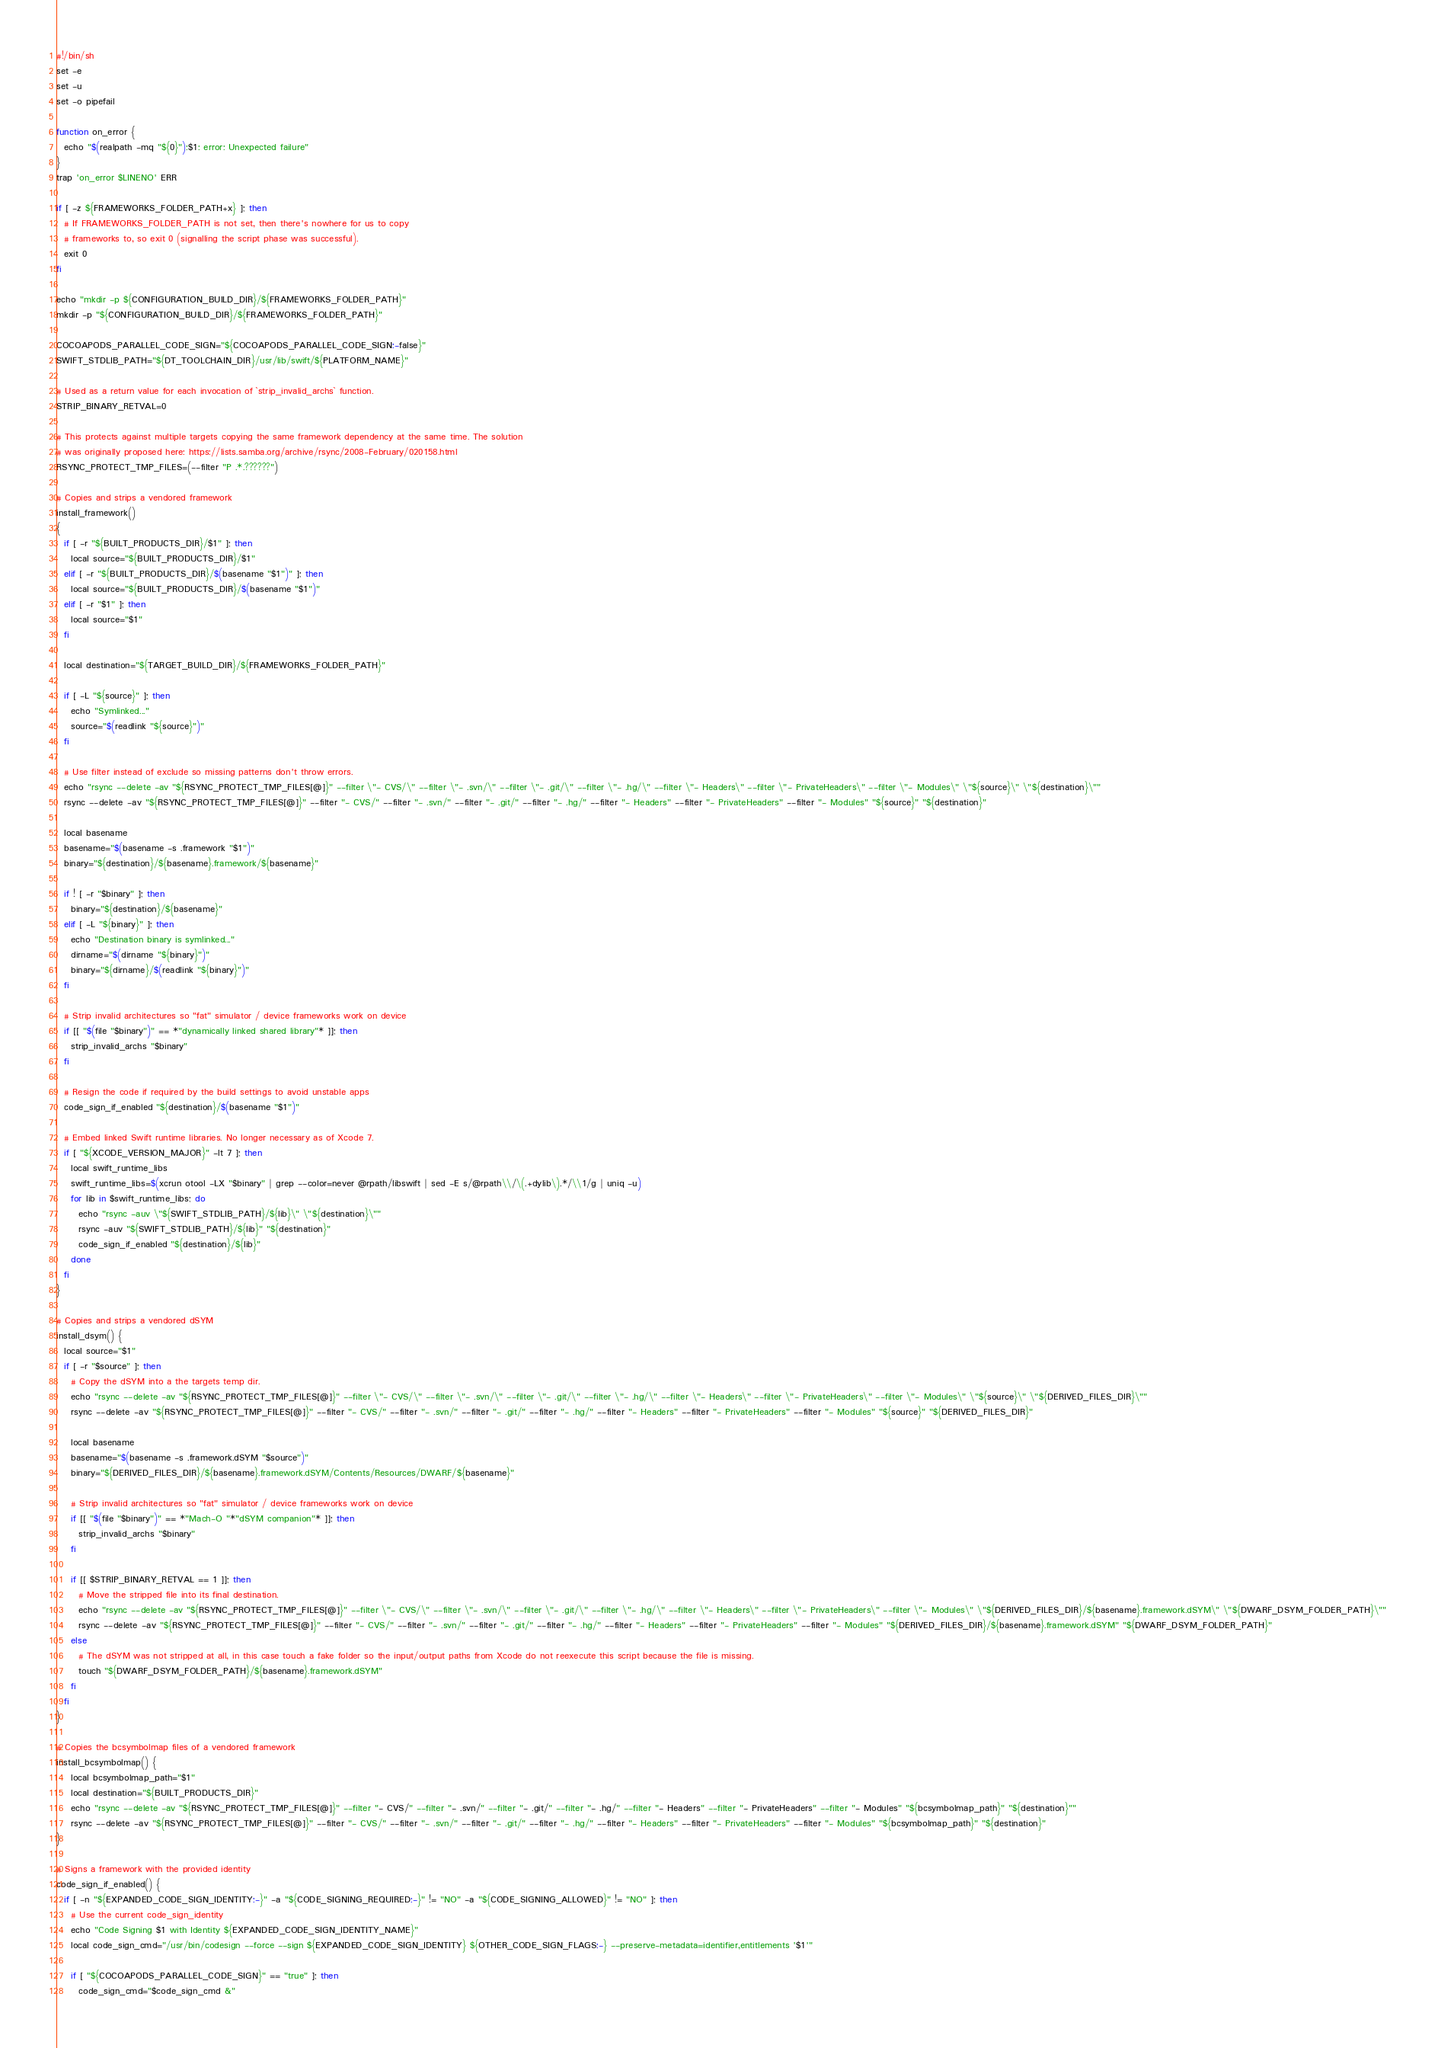<code> <loc_0><loc_0><loc_500><loc_500><_Bash_>#!/bin/sh
set -e
set -u
set -o pipefail

function on_error {
  echo "$(realpath -mq "${0}"):$1: error: Unexpected failure"
}
trap 'on_error $LINENO' ERR

if [ -z ${FRAMEWORKS_FOLDER_PATH+x} ]; then
  # If FRAMEWORKS_FOLDER_PATH is not set, then there's nowhere for us to copy
  # frameworks to, so exit 0 (signalling the script phase was successful).
  exit 0
fi

echo "mkdir -p ${CONFIGURATION_BUILD_DIR}/${FRAMEWORKS_FOLDER_PATH}"
mkdir -p "${CONFIGURATION_BUILD_DIR}/${FRAMEWORKS_FOLDER_PATH}"

COCOAPODS_PARALLEL_CODE_SIGN="${COCOAPODS_PARALLEL_CODE_SIGN:-false}"
SWIFT_STDLIB_PATH="${DT_TOOLCHAIN_DIR}/usr/lib/swift/${PLATFORM_NAME}"

# Used as a return value for each invocation of `strip_invalid_archs` function.
STRIP_BINARY_RETVAL=0

# This protects against multiple targets copying the same framework dependency at the same time. The solution
# was originally proposed here: https://lists.samba.org/archive/rsync/2008-February/020158.html
RSYNC_PROTECT_TMP_FILES=(--filter "P .*.??????")

# Copies and strips a vendored framework
install_framework()
{
  if [ -r "${BUILT_PRODUCTS_DIR}/$1" ]; then
    local source="${BUILT_PRODUCTS_DIR}/$1"
  elif [ -r "${BUILT_PRODUCTS_DIR}/$(basename "$1")" ]; then
    local source="${BUILT_PRODUCTS_DIR}/$(basename "$1")"
  elif [ -r "$1" ]; then
    local source="$1"
  fi

  local destination="${TARGET_BUILD_DIR}/${FRAMEWORKS_FOLDER_PATH}"

  if [ -L "${source}" ]; then
    echo "Symlinked..."
    source="$(readlink "${source}")"
  fi

  # Use filter instead of exclude so missing patterns don't throw errors.
  echo "rsync --delete -av "${RSYNC_PROTECT_TMP_FILES[@]}" --filter \"- CVS/\" --filter \"- .svn/\" --filter \"- .git/\" --filter \"- .hg/\" --filter \"- Headers\" --filter \"- PrivateHeaders\" --filter \"- Modules\" \"${source}\" \"${destination}\""
  rsync --delete -av "${RSYNC_PROTECT_TMP_FILES[@]}" --filter "- CVS/" --filter "- .svn/" --filter "- .git/" --filter "- .hg/" --filter "- Headers" --filter "- PrivateHeaders" --filter "- Modules" "${source}" "${destination}"

  local basename
  basename="$(basename -s .framework "$1")"
  binary="${destination}/${basename}.framework/${basename}"

  if ! [ -r "$binary" ]; then
    binary="${destination}/${basename}"
  elif [ -L "${binary}" ]; then
    echo "Destination binary is symlinked..."
    dirname="$(dirname "${binary}")"
    binary="${dirname}/$(readlink "${binary}")"
  fi

  # Strip invalid architectures so "fat" simulator / device frameworks work on device
  if [[ "$(file "$binary")" == *"dynamically linked shared library"* ]]; then
    strip_invalid_archs "$binary"
  fi

  # Resign the code if required by the build settings to avoid unstable apps
  code_sign_if_enabled "${destination}/$(basename "$1")"

  # Embed linked Swift runtime libraries. No longer necessary as of Xcode 7.
  if [ "${XCODE_VERSION_MAJOR}" -lt 7 ]; then
    local swift_runtime_libs
    swift_runtime_libs=$(xcrun otool -LX "$binary" | grep --color=never @rpath/libswift | sed -E s/@rpath\\/\(.+dylib\).*/\\1/g | uniq -u)
    for lib in $swift_runtime_libs; do
      echo "rsync -auv \"${SWIFT_STDLIB_PATH}/${lib}\" \"${destination}\""
      rsync -auv "${SWIFT_STDLIB_PATH}/${lib}" "${destination}"
      code_sign_if_enabled "${destination}/${lib}"
    done
  fi
}

# Copies and strips a vendored dSYM
install_dsym() {
  local source="$1"
  if [ -r "$source" ]; then
    # Copy the dSYM into a the targets temp dir.
    echo "rsync --delete -av "${RSYNC_PROTECT_TMP_FILES[@]}" --filter \"- CVS/\" --filter \"- .svn/\" --filter \"- .git/\" --filter \"- .hg/\" --filter \"- Headers\" --filter \"- PrivateHeaders\" --filter \"- Modules\" \"${source}\" \"${DERIVED_FILES_DIR}\""
    rsync --delete -av "${RSYNC_PROTECT_TMP_FILES[@]}" --filter "- CVS/" --filter "- .svn/" --filter "- .git/" --filter "- .hg/" --filter "- Headers" --filter "- PrivateHeaders" --filter "- Modules" "${source}" "${DERIVED_FILES_DIR}"

    local basename
    basename="$(basename -s .framework.dSYM "$source")"
    binary="${DERIVED_FILES_DIR}/${basename}.framework.dSYM/Contents/Resources/DWARF/${basename}"

    # Strip invalid architectures so "fat" simulator / device frameworks work on device
    if [[ "$(file "$binary")" == *"Mach-O "*"dSYM companion"* ]]; then
      strip_invalid_archs "$binary"
    fi

    if [[ $STRIP_BINARY_RETVAL == 1 ]]; then
      # Move the stripped file into its final destination.
      echo "rsync --delete -av "${RSYNC_PROTECT_TMP_FILES[@]}" --filter \"- CVS/\" --filter \"- .svn/\" --filter \"- .git/\" --filter \"- .hg/\" --filter \"- Headers\" --filter \"- PrivateHeaders\" --filter \"- Modules\" \"${DERIVED_FILES_DIR}/${basename}.framework.dSYM\" \"${DWARF_DSYM_FOLDER_PATH}\""
      rsync --delete -av "${RSYNC_PROTECT_TMP_FILES[@]}" --filter "- CVS/" --filter "- .svn/" --filter "- .git/" --filter "- .hg/" --filter "- Headers" --filter "- PrivateHeaders" --filter "- Modules" "${DERIVED_FILES_DIR}/${basename}.framework.dSYM" "${DWARF_DSYM_FOLDER_PATH}"
    else
      # The dSYM was not stripped at all, in this case touch a fake folder so the input/output paths from Xcode do not reexecute this script because the file is missing.
      touch "${DWARF_DSYM_FOLDER_PATH}/${basename}.framework.dSYM"
    fi
  fi
}

# Copies the bcsymbolmap files of a vendored framework
install_bcsymbolmap() {
    local bcsymbolmap_path="$1"
    local destination="${BUILT_PRODUCTS_DIR}"
    echo "rsync --delete -av "${RSYNC_PROTECT_TMP_FILES[@]}" --filter "- CVS/" --filter "- .svn/" --filter "- .git/" --filter "- .hg/" --filter "- Headers" --filter "- PrivateHeaders" --filter "- Modules" "${bcsymbolmap_path}" "${destination}""
    rsync --delete -av "${RSYNC_PROTECT_TMP_FILES[@]}" --filter "- CVS/" --filter "- .svn/" --filter "- .git/" --filter "- .hg/" --filter "- Headers" --filter "- PrivateHeaders" --filter "- Modules" "${bcsymbolmap_path}" "${destination}"
}

# Signs a framework with the provided identity
code_sign_if_enabled() {
  if [ -n "${EXPANDED_CODE_SIGN_IDENTITY:-}" -a "${CODE_SIGNING_REQUIRED:-}" != "NO" -a "${CODE_SIGNING_ALLOWED}" != "NO" ]; then
    # Use the current code_sign_identity
    echo "Code Signing $1 with Identity ${EXPANDED_CODE_SIGN_IDENTITY_NAME}"
    local code_sign_cmd="/usr/bin/codesign --force --sign ${EXPANDED_CODE_SIGN_IDENTITY} ${OTHER_CODE_SIGN_FLAGS:-} --preserve-metadata=identifier,entitlements '$1'"

    if [ "${COCOAPODS_PARALLEL_CODE_SIGN}" == "true" ]; then
      code_sign_cmd="$code_sign_cmd &"</code> 